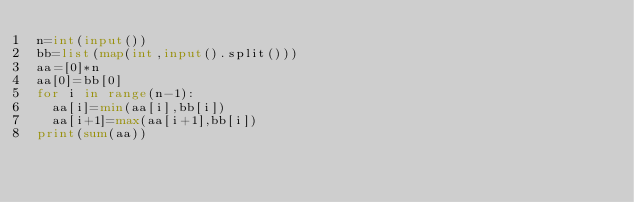Convert code to text. <code><loc_0><loc_0><loc_500><loc_500><_Python_>n=int(input())
bb=list(map(int,input().split()))
aa=[0]*n
aa[0]=bb[0]
for i in range(n-1):
  aa[i]=min(aa[i],bb[i])
  aa[i+1]=max(aa[i+1],bb[i])
print(sum(aa))
</code> 